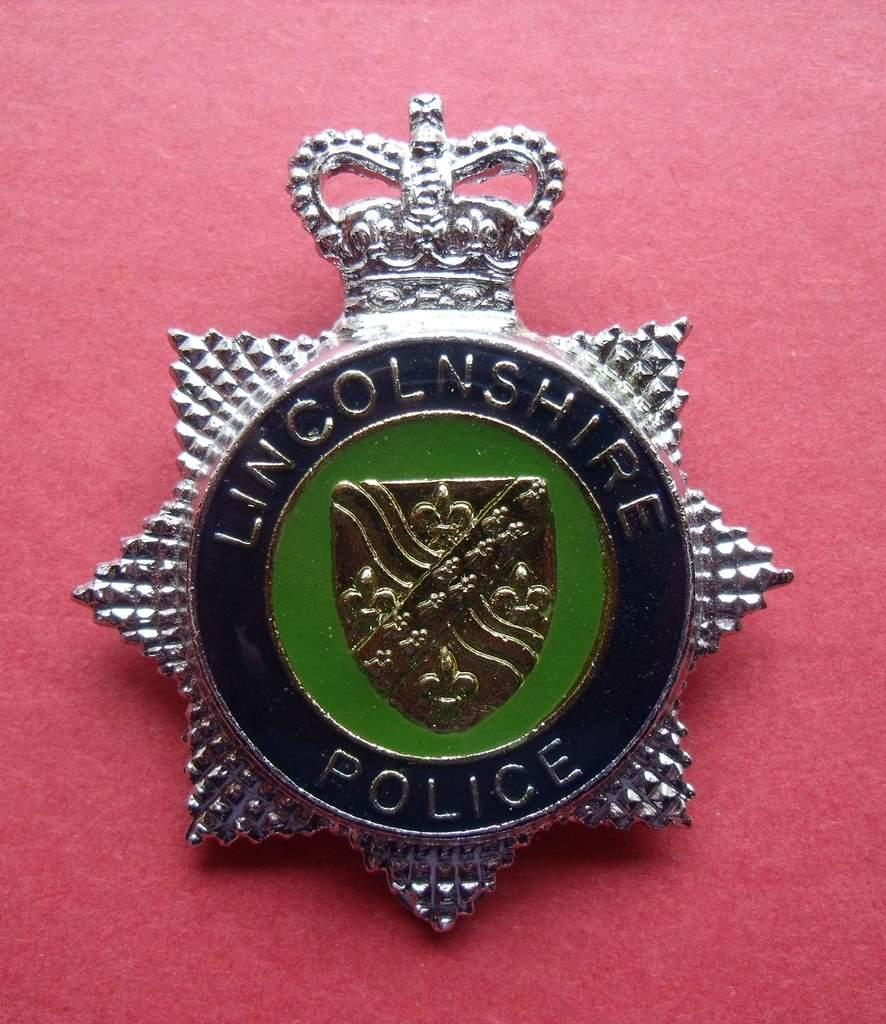What is the main subject of the image? The main subject of the image is a batch. What is the color of the surface on which the batch is placed? The surface is red in color. Is there any text present on the batch? Yes, there is text written on the batch. What type of country is depicted in the image? There is no country depicted in the image; it features a batch on a red surface with text. Can you tell me how many people are playing the game in the image? There is no game present in the image; it features a batch on a red surface with text. 